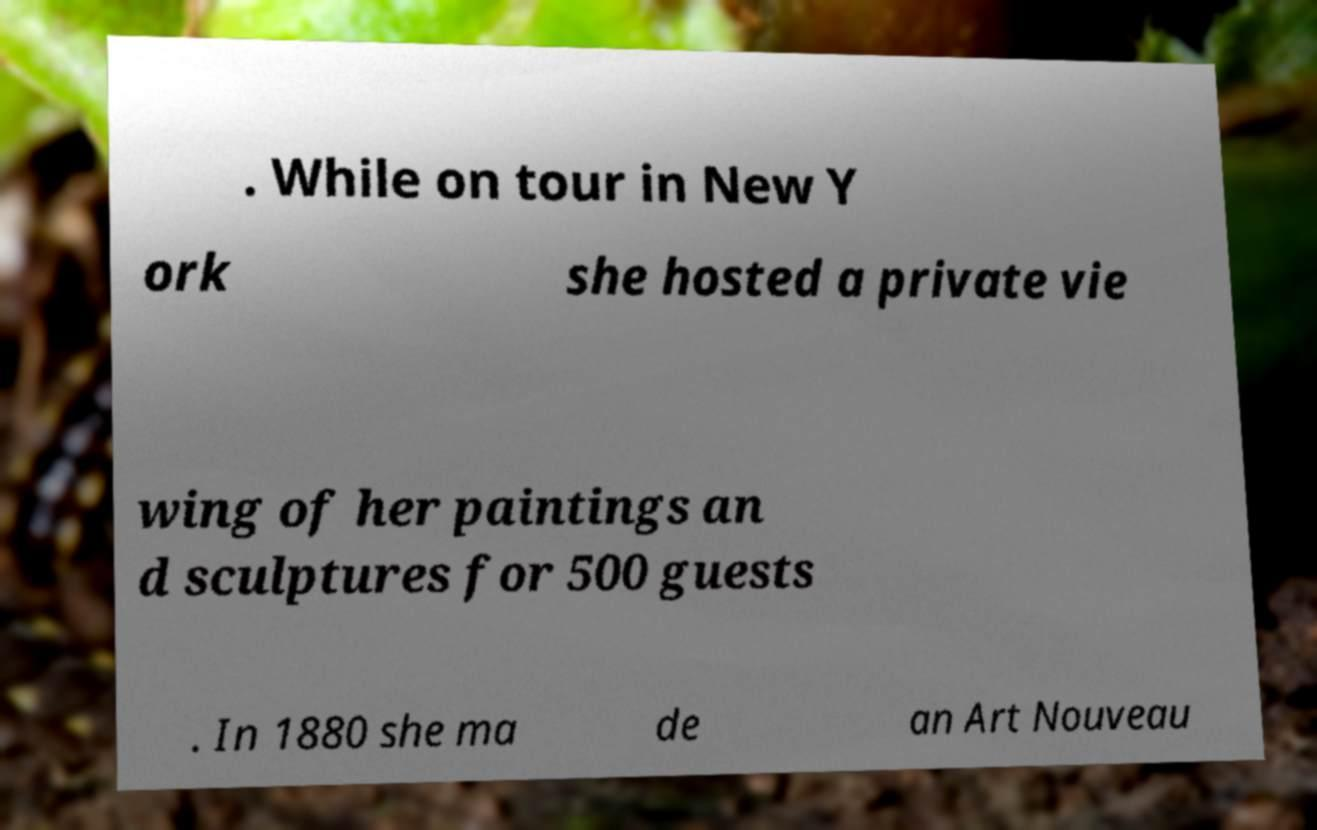Could you extract and type out the text from this image? . While on tour in New Y ork she hosted a private vie wing of her paintings an d sculptures for 500 guests . In 1880 she ma de an Art Nouveau 